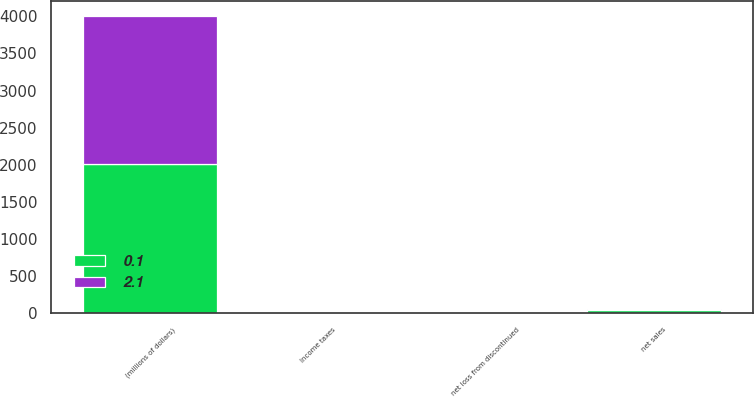Convert chart. <chart><loc_0><loc_0><loc_500><loc_500><stacked_bar_chart><ecel><fcel>(millions of dollars)<fcel>net sales<fcel>Income taxes<fcel>net loss from discontinued<nl><fcel>2.1<fcel>2006<fcel>12<fcel>0.1<fcel>0.1<nl><fcel>0.1<fcel>2005<fcel>38.7<fcel>0.9<fcel>2.1<nl></chart> 